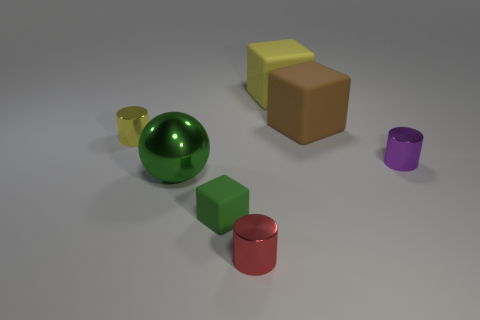Add 1 tiny green rubber blocks. How many objects exist? 8 Subtract all cubes. How many objects are left? 4 Subtract 1 yellow cubes. How many objects are left? 6 Subtract all tiny yellow shiny cylinders. Subtract all big yellow blocks. How many objects are left? 5 Add 7 tiny red cylinders. How many tiny red cylinders are left? 8 Add 4 brown cylinders. How many brown cylinders exist? 4 